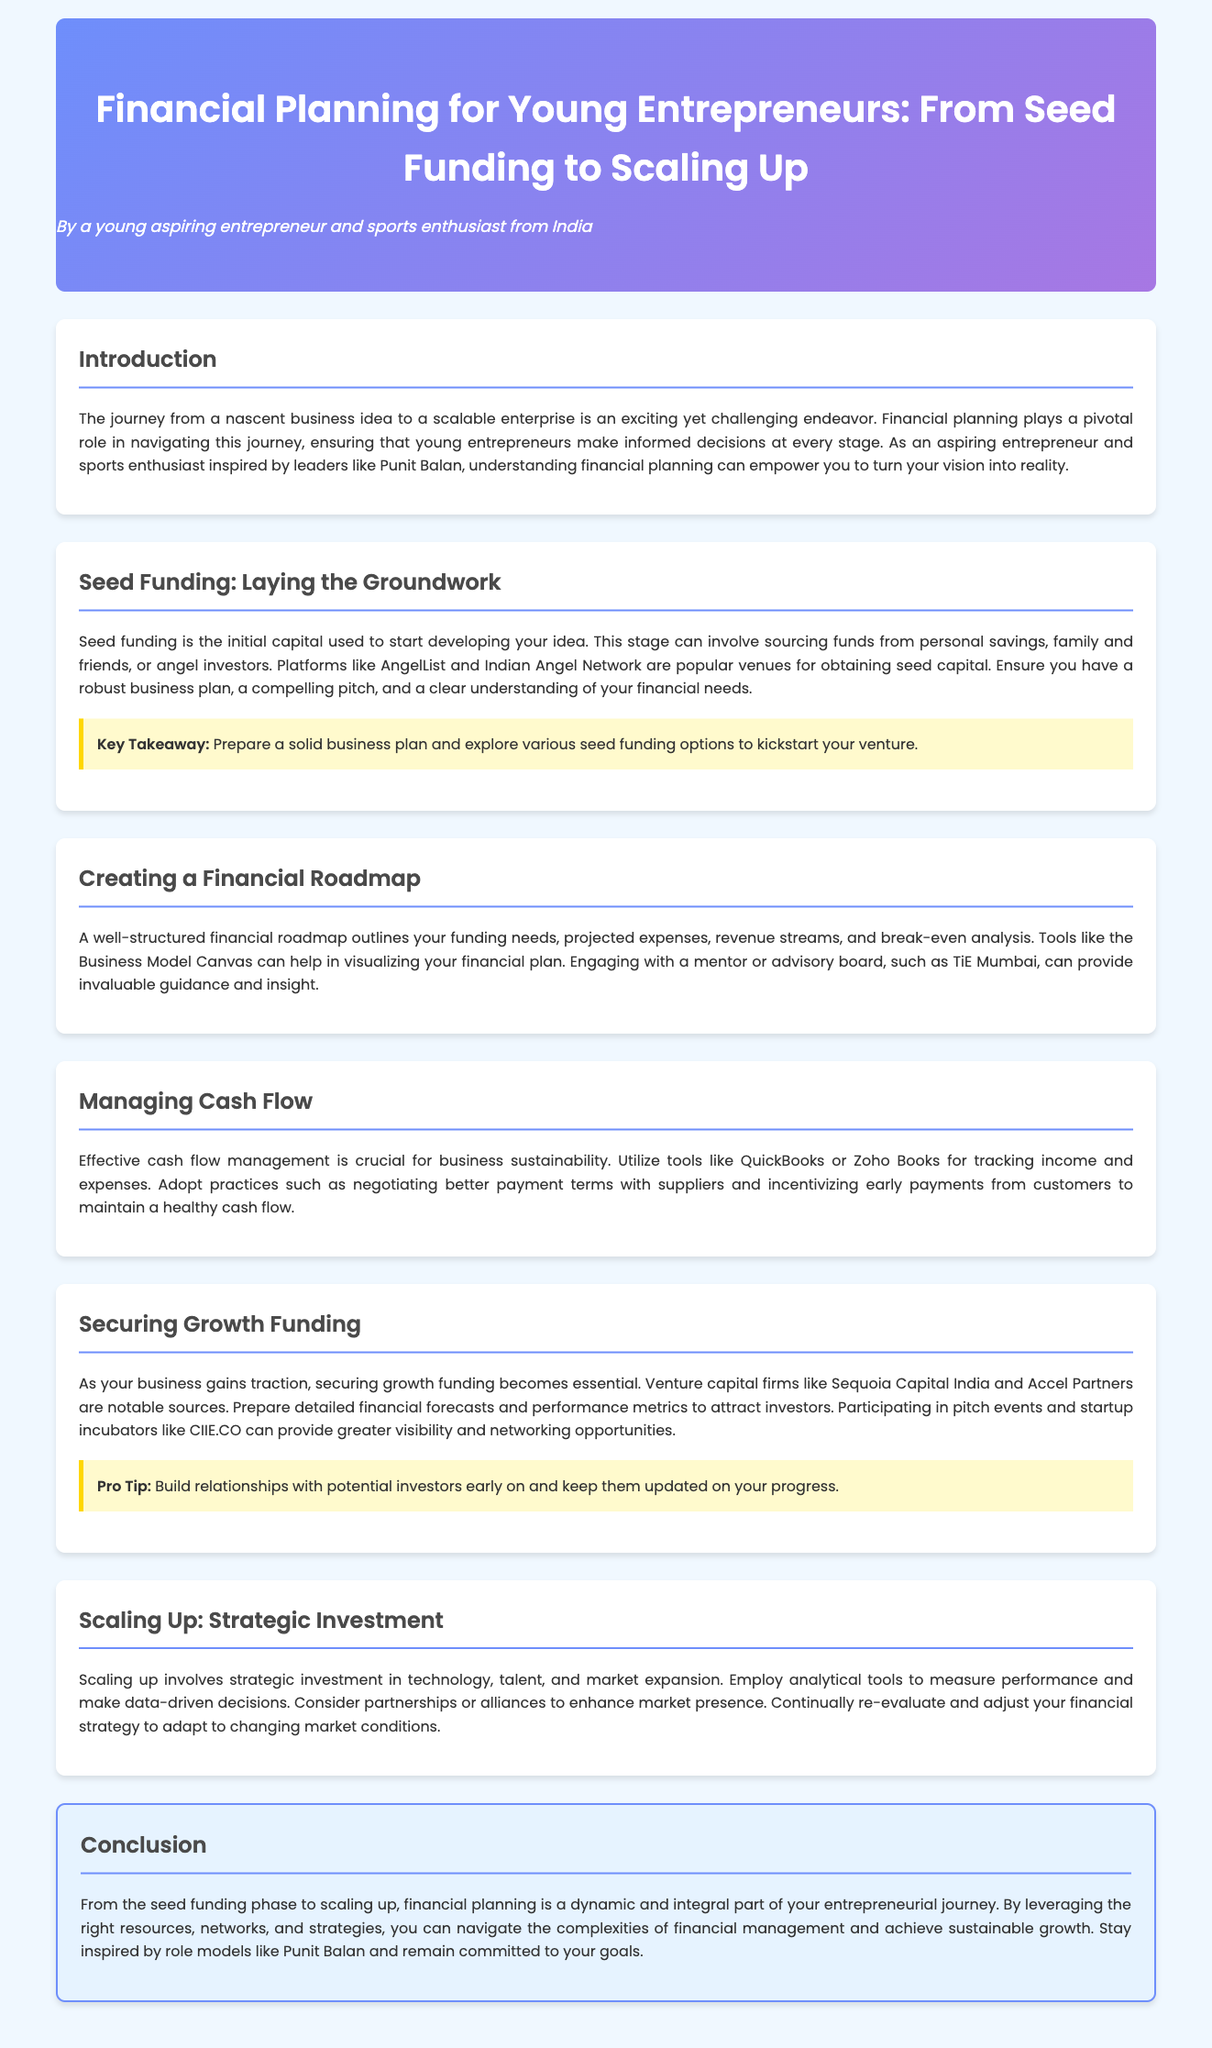what is the title of the document? The title is prominently displayed at the top of the document, indicating the focus on financial planning for young entrepreneurs.
Answer: Financial Planning for Young Entrepreneurs: From Seed Funding to Scaling Up who is the author of the document? The author is mentioned in the header section, identifying their background as a young aspiring entrepreneur and sports enthusiast from India.
Answer: A young aspiring entrepreneur and sports enthusiast from India what is seed funding? The definition of seed funding is given in the section about laying the groundwork, describing it as initial capital for developing an idea.
Answer: Initial capital used to start developing your idea which platforms are mentioned for obtaining seed capital? The document lists platforms where entrepreneurs can seek to obtain seed funding in the seed funding section.
Answer: AngelList and Indian Angel Network what is a key takeaway from the seed funding section? A highlighted takeaway from the corresponding section emphasizes the importance of preparation in securing seed funds.
Answer: Prepare a solid business plan and explore various seed funding options what tools are suggested for cash flow management? The document provides specific tools recommended for tracking financial activities in the cash flow management section.
Answer: QuickBooks or Zoho Books name one venture capital firm mentioned in securing growth funding. In the section about securing growth funding, specific venture capital firms are identified as key sources of funding.
Answer: Sequoia Capital India what should you prepare to attract investors? The document suggests specific items that entrepreneurs should prepare to make a compelling case to attract investors.
Answer: Detailed financial forecasts and performance metrics what is the role of partnerships in scaling up? The document discusses the significance of partnerships within the strategic investment aspect of scaling up.
Answer: Enhance market presence what is the final message in the conclusion section? The conclusion reinforces a motivational thought about the entrepreneurial journey and the importance of financial planning.
Answer: Stay inspired by role models like Punit Balan and remain committed to your goals 